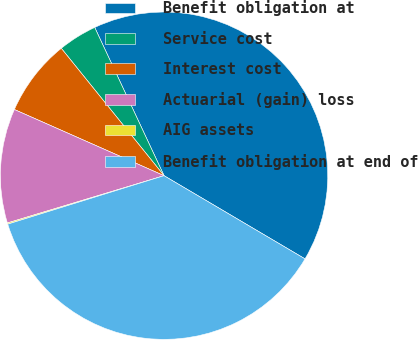Convert chart. <chart><loc_0><loc_0><loc_500><loc_500><pie_chart><fcel>Benefit obligation at<fcel>Service cost<fcel>Interest cost<fcel>Actuarial (gain) loss<fcel>AIG assets<fcel>Benefit obligation at end of<nl><fcel>40.45%<fcel>3.84%<fcel>7.57%<fcel>11.29%<fcel>0.12%<fcel>36.73%<nl></chart> 